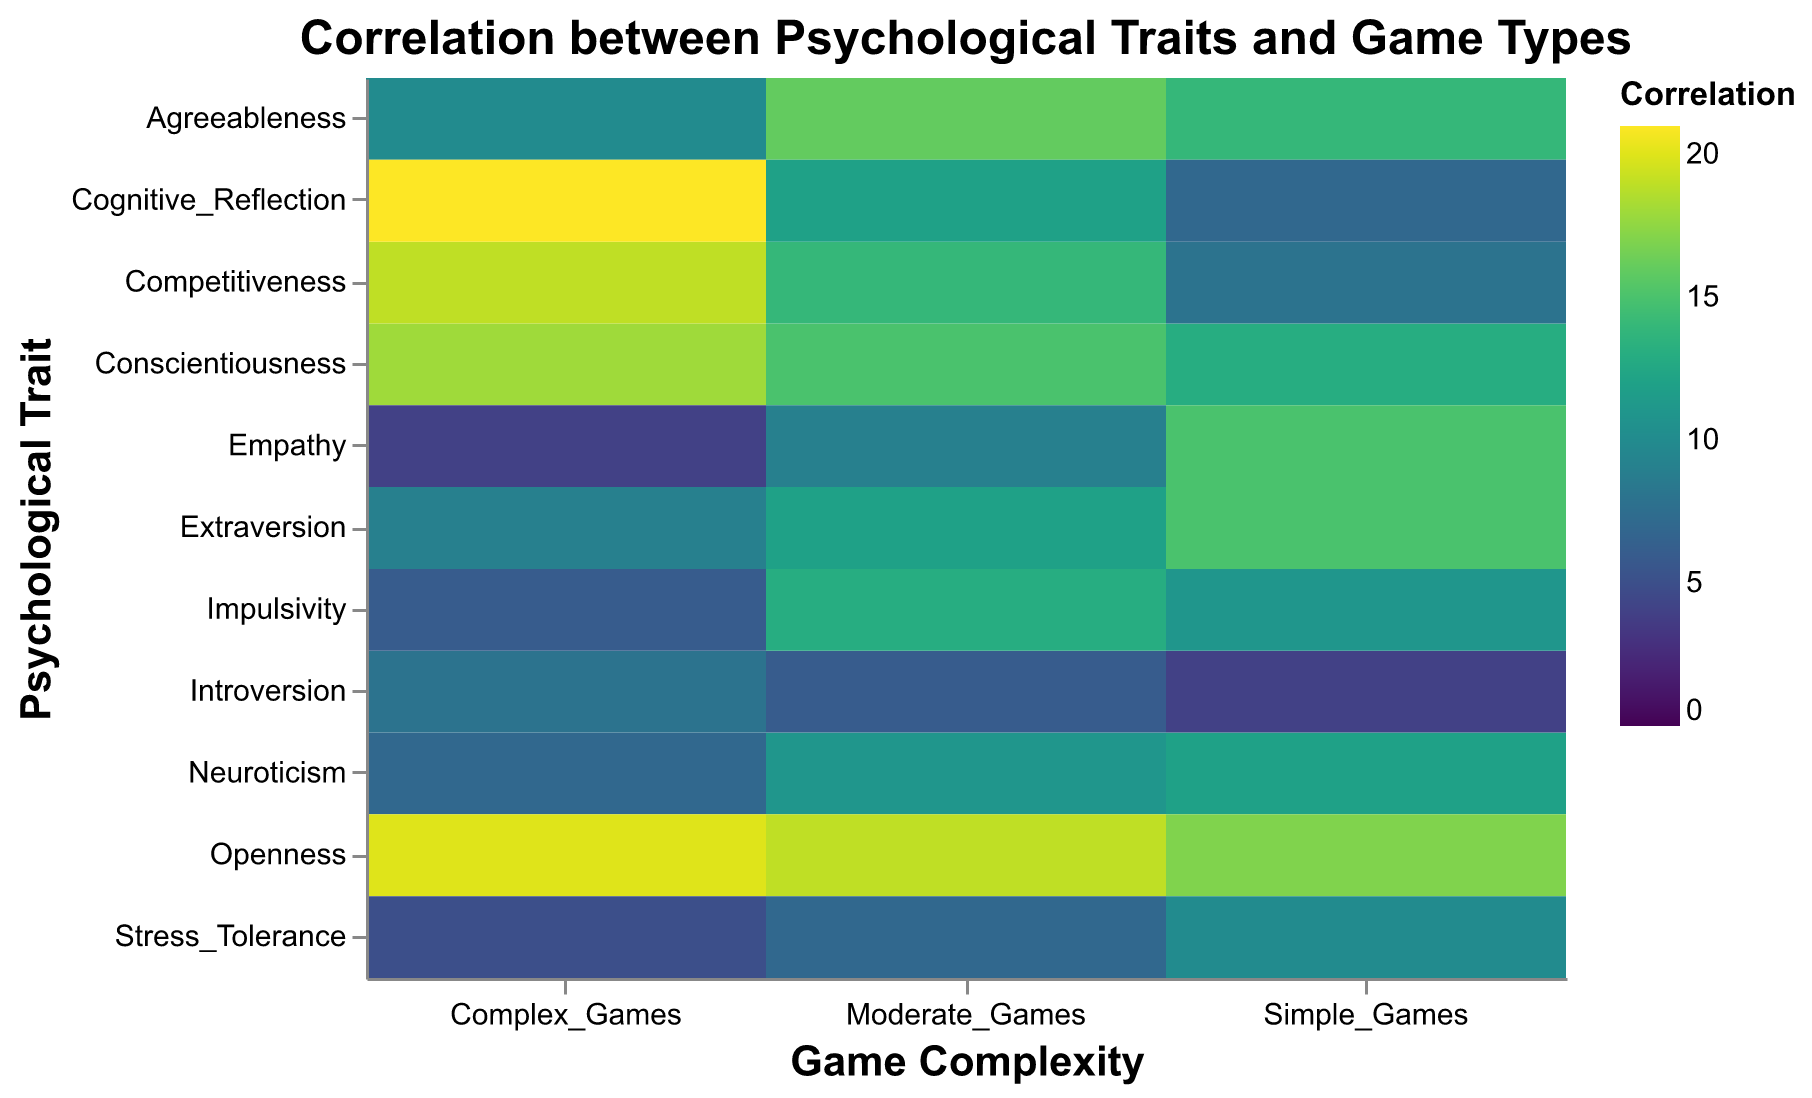What is the title of the heatmap? The title of the heatmap is located at the top center of the figure, usually in a larger font size. The title provides a brief description of what the figure represents.
Answer: Correlation between Psychological Traits and Game Types Which psychological trait has the highest correlation with Complex Games? Examine the color that correlates with the highest value on the rightmost column labeled 'Complex Games'.
Answer: Cognitive Reflection Which psychological trait is most strongly correlated with Simple Games? Find the psychological trait with the darkest color in the column labeled 'Simple Games'.
Answer: Openness What is the correlation value of Agreeableness with Moderate Games? Locate the cell where the row labeled 'Agreeableness' intersects with the column labeled 'Moderate Games'.
Answer: 16 What is the difference in the correlation values of Empathy between Simple Games and Complex Games? Locate the values for 'Empathy' under both 'Simple Games' and 'Complex Games' and calculate the difference (15 - 4).
Answer: 11 Which psychological trait has the lowest correlation with Stress Tolerance for Complex Games? Check the values under 'Complex Games' and find the lowest value.
Answer: Stress Tolerance Compare the correlation values for Competitiveness between Moderate Games and Complex Games. Which one is higher? Check the values for 'Competitiveness' under 'Moderate Games' and 'Complex Games' and determine which is higher.
Answer: Complex Games How many psychological traits have a higher correlation with Simple Games than with Moderate Games? Compare values of each psychological trait under 'Simple Games' and 'Moderate Games'. Count how many times the value for 'Simple Games' is greater.
Answer: 4 What is the median correlation value for Complex Games? List the correlation values for 'Complex Games', sort them, and find the middle value. The values are 4, 5, 6, 7, 8, 9, 10, 18, 19, 20, 21; so, the median is the middle one (7th value).
Answer: 10 Which psychological trait shows a consistent increase in correlation values from Simple Games to Complex Games? Examine the trend of values from 'Simple Games' to 'Moderate Games' to 'Complex Games' for each trait.
Answer: Cognitive Reflection 